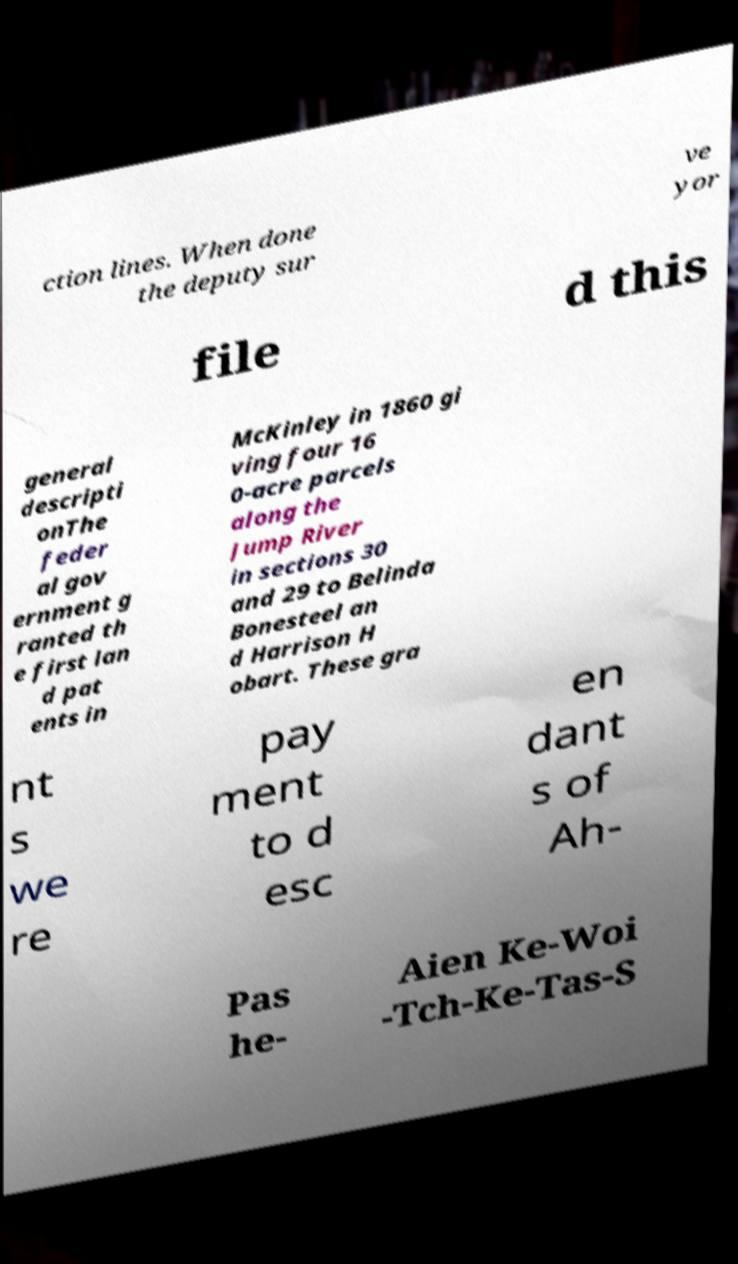What messages or text are displayed in this image? I need them in a readable, typed format. ction lines. When done the deputy sur ve yor file d this general descripti onThe feder al gov ernment g ranted th e first lan d pat ents in McKinley in 1860 gi ving four 16 0-acre parcels along the Jump River in sections 30 and 29 to Belinda Bonesteel an d Harrison H obart. These gra nt s we re pay ment to d esc en dant s of Ah- Pas he- Aien Ke-Woi -Tch-Ke-Tas-S 